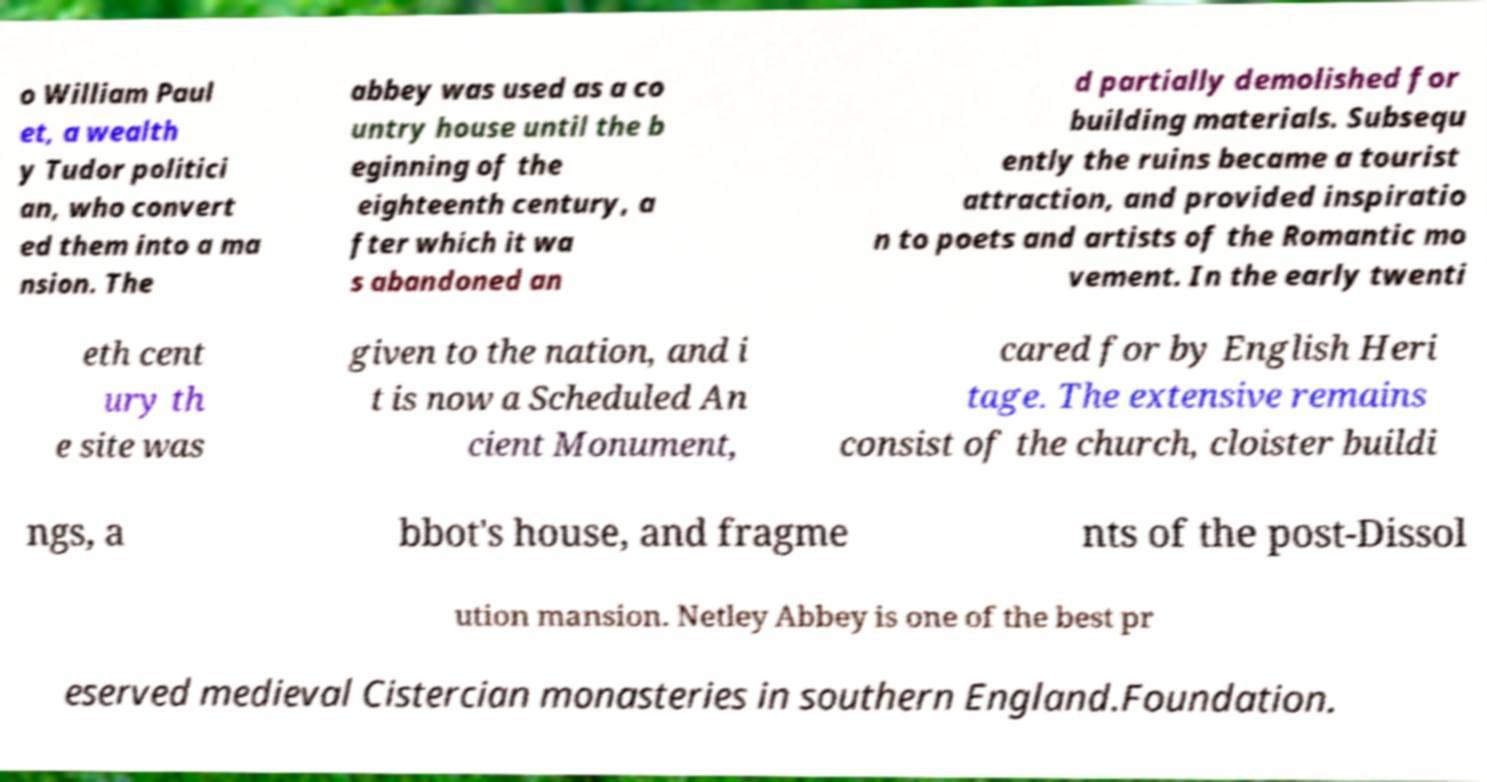Could you assist in decoding the text presented in this image and type it out clearly? o William Paul et, a wealth y Tudor politici an, who convert ed them into a ma nsion. The abbey was used as a co untry house until the b eginning of the eighteenth century, a fter which it wa s abandoned an d partially demolished for building materials. Subsequ ently the ruins became a tourist attraction, and provided inspiratio n to poets and artists of the Romantic mo vement. In the early twenti eth cent ury th e site was given to the nation, and i t is now a Scheduled An cient Monument, cared for by English Heri tage. The extensive remains consist of the church, cloister buildi ngs, a bbot's house, and fragme nts of the post-Dissol ution mansion. Netley Abbey is one of the best pr eserved medieval Cistercian monasteries in southern England.Foundation. 